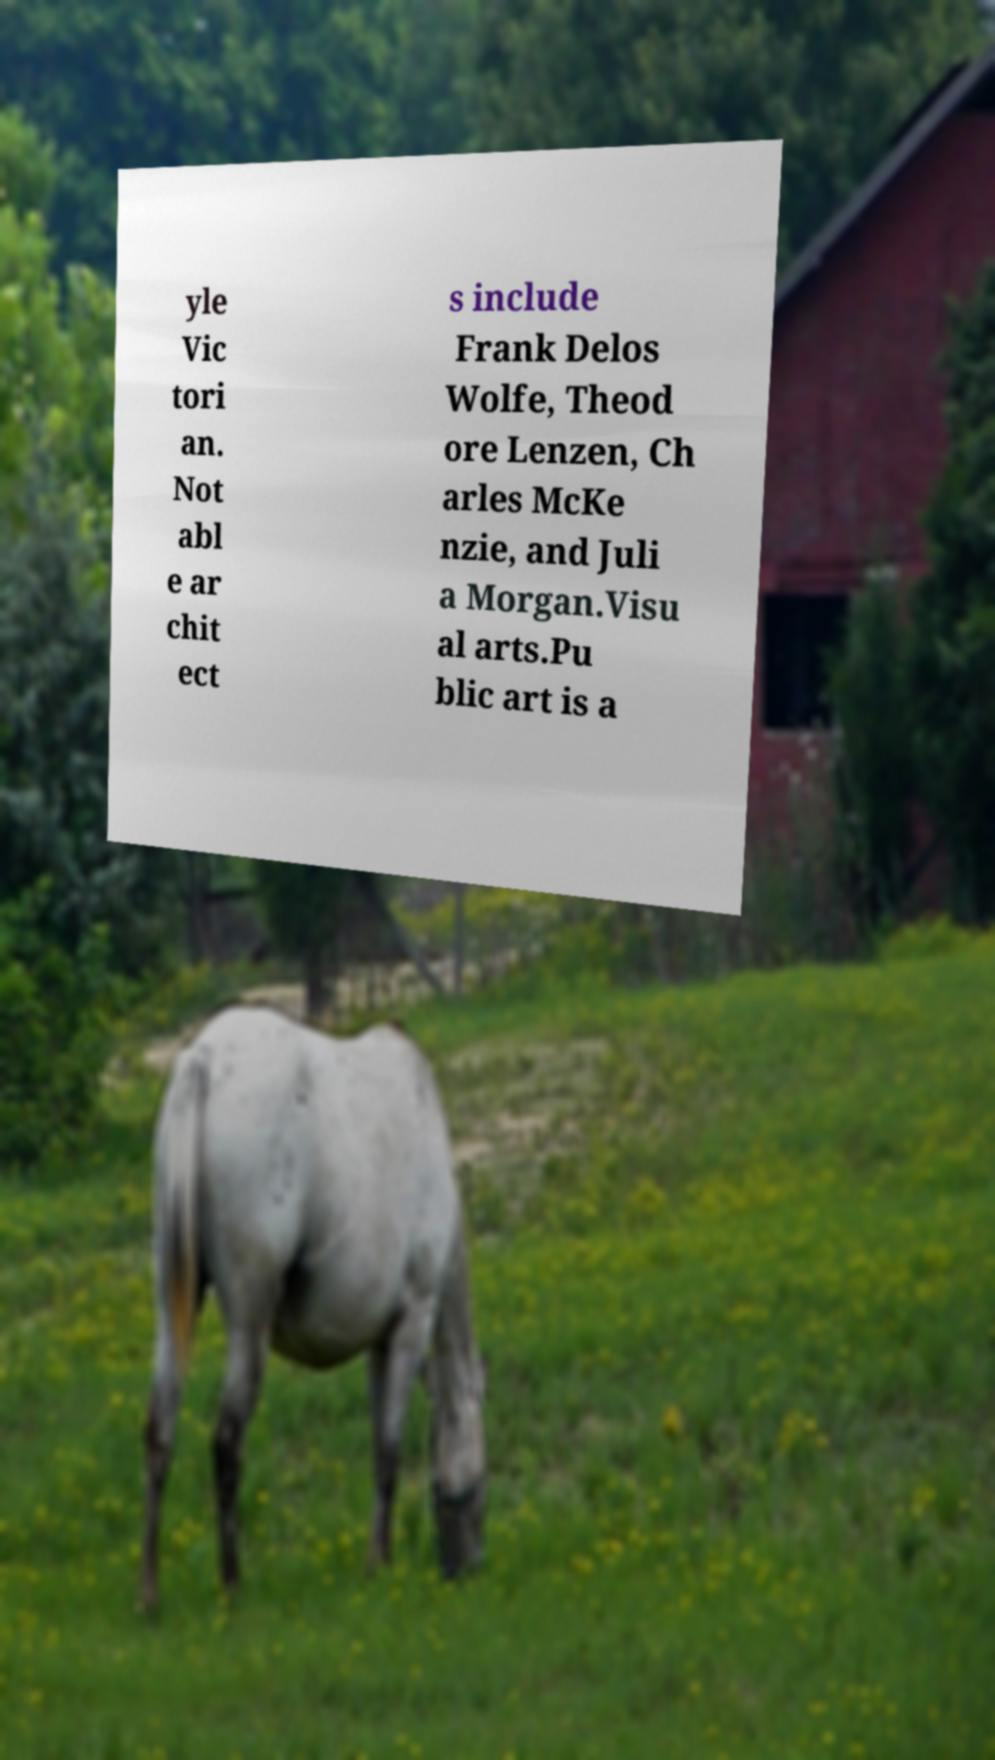Please read and relay the text visible in this image. What does it say? yle Vic tori an. Not abl e ar chit ect s include Frank Delos Wolfe, Theod ore Lenzen, Ch arles McKe nzie, and Juli a Morgan.Visu al arts.Pu blic art is a 